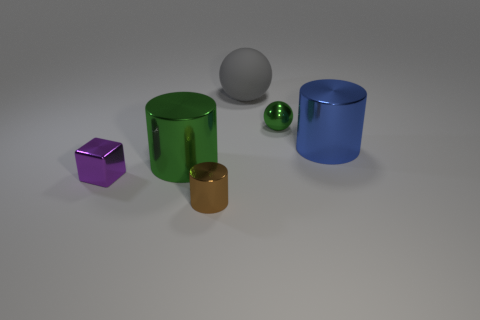How are the objects arranged in relation to one another? The objects are spread out on a flat surface with ample space between them. The purple and brown objects are positionally similar, while the blue and green objects stand upright, creating a visually balanced distribution. 